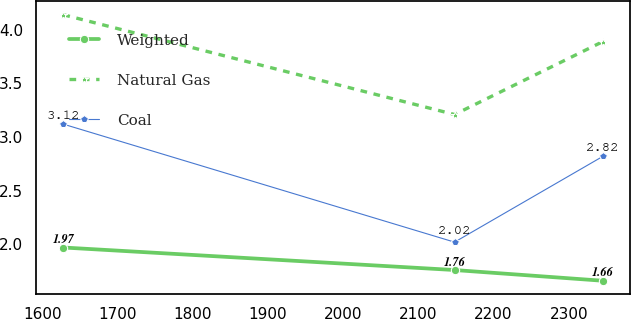Convert chart. <chart><loc_0><loc_0><loc_500><loc_500><line_chart><ecel><fcel>Weighted<fcel>Natural Gas<fcel>Coal<nl><fcel>1627.99<fcel>1.97<fcel>4.14<fcel>3.12<nl><fcel>2148.06<fcel>1.76<fcel>3.21<fcel>2.02<nl><fcel>2345.28<fcel>1.66<fcel>3.89<fcel>2.82<nl></chart> 